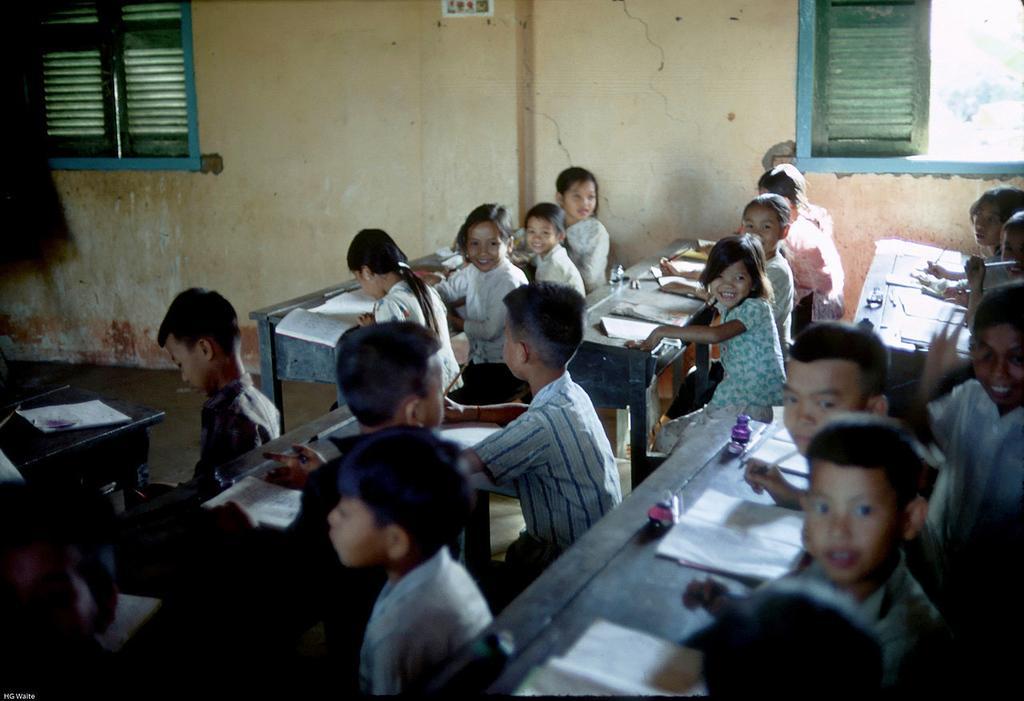How would you summarize this image in a sentence or two? In this image there are kids sitting on benches, in front of them there are books, in the background there is a wall for that wall there are windows. 